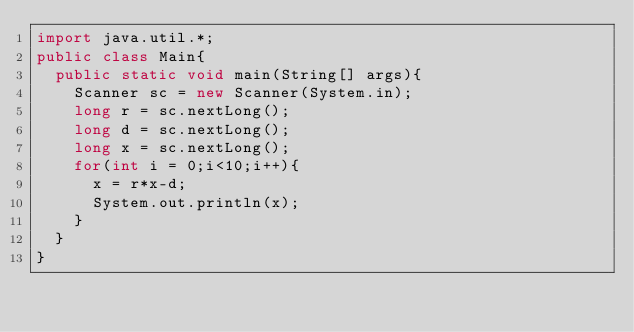<code> <loc_0><loc_0><loc_500><loc_500><_Java_>import java.util.*;
public class Main{
  public static void main(String[] args){
    Scanner sc = new Scanner(System.in);
    long r = sc.nextLong();
    long d = sc.nextLong();
    long x = sc.nextLong();
    for(int i = 0;i<10;i++){
      x = r*x-d;
      System.out.println(x);
    }
  }
}
</code> 